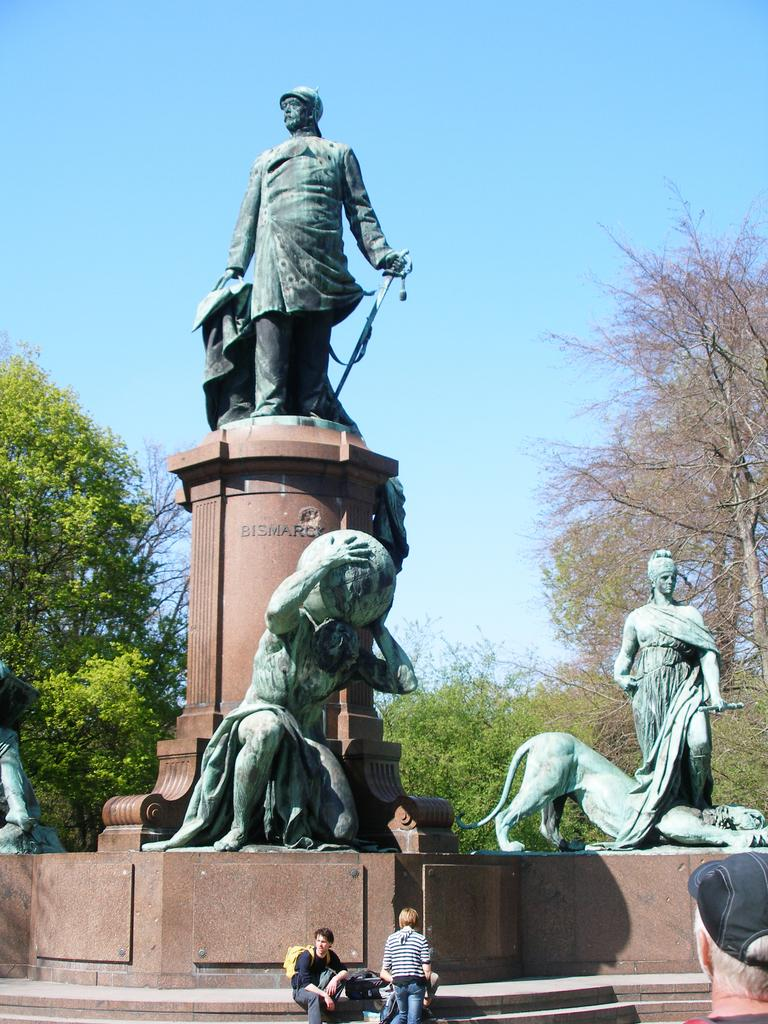What type of objects can be seen in the image? There are statues in the image. What else can be seen in the image besides the statues? There are trees in the image. How are the statues positioned in the image? Some statues are sitting, and some are standing. What is the color of the sky in the image? The sky is blue in the image. What type of bean is growing on the statue in the image? There are no beans present in the image, and the statues are not depicted as growing anything. 